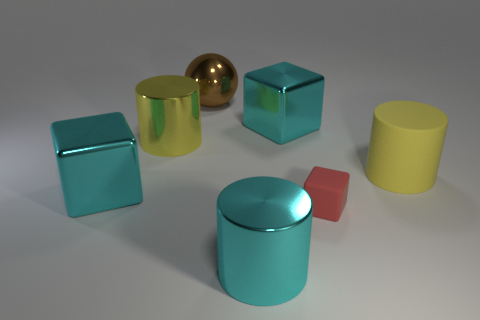How many objects in the picture are not cubes? In the image, we can identify three objects that are not cubes: a gold sphere, a yellow cylinder, and a red smaller cube which differ from the standard larger cubes present. Can you describe the arrangement of the objects? The objects are arranged with ample space between them on a flat surface. They form no discernible pattern, and their placement appears casual, focusing on showcasing each object clearly rather than creating a composition. 